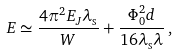Convert formula to latex. <formula><loc_0><loc_0><loc_500><loc_500>E \simeq \frac { 4 \pi ^ { 2 } E _ { J } \lambda _ { \text {s} } } { W } + \frac { \Phi _ { 0 } ^ { 2 } d } { 1 6 \lambda _ { \text {s} } \lambda } \, ,</formula> 